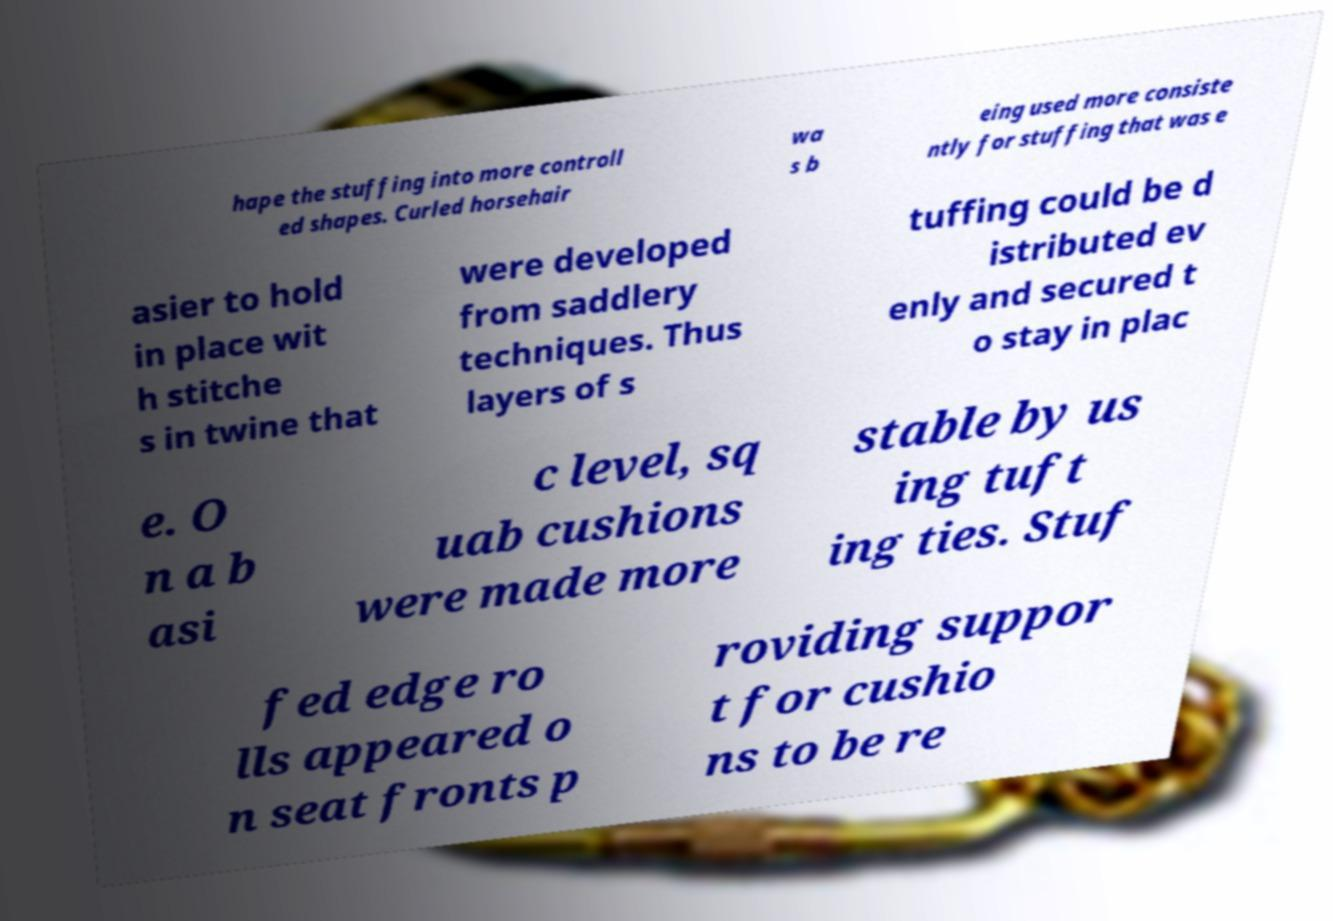What messages or text are displayed in this image? I need them in a readable, typed format. hape the stuffing into more controll ed shapes. Curled horsehair wa s b eing used more consiste ntly for stuffing that was e asier to hold in place wit h stitche s in twine that were developed from saddlery techniques. Thus layers of s tuffing could be d istributed ev enly and secured t o stay in plac e. O n a b asi c level, sq uab cushions were made more stable by us ing tuft ing ties. Stuf fed edge ro lls appeared o n seat fronts p roviding suppor t for cushio ns to be re 